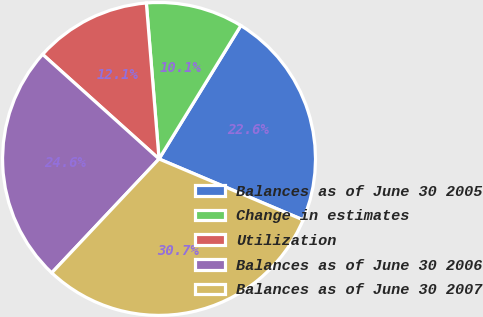Convert chart to OTSL. <chart><loc_0><loc_0><loc_500><loc_500><pie_chart><fcel>Balances as of June 30 2005<fcel>Change in estimates<fcel>Utilization<fcel>Balances as of June 30 2006<fcel>Balances as of June 30 2007<nl><fcel>22.61%<fcel>10.05%<fcel>12.06%<fcel>24.62%<fcel>30.65%<nl></chart> 